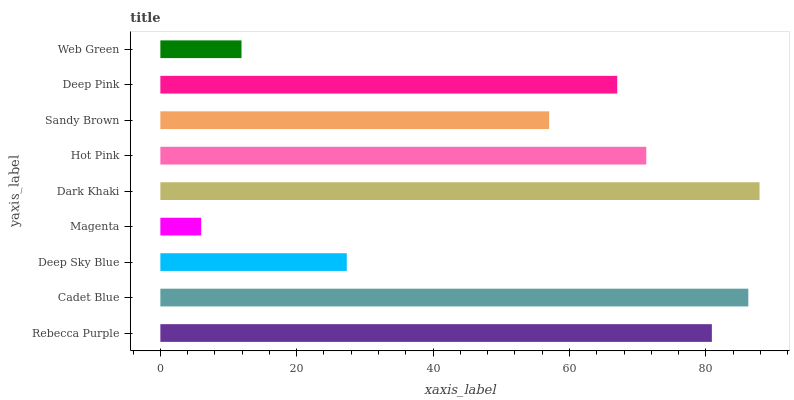Is Magenta the minimum?
Answer yes or no. Yes. Is Dark Khaki the maximum?
Answer yes or no. Yes. Is Cadet Blue the minimum?
Answer yes or no. No. Is Cadet Blue the maximum?
Answer yes or no. No. Is Cadet Blue greater than Rebecca Purple?
Answer yes or no. Yes. Is Rebecca Purple less than Cadet Blue?
Answer yes or no. Yes. Is Rebecca Purple greater than Cadet Blue?
Answer yes or no. No. Is Cadet Blue less than Rebecca Purple?
Answer yes or no. No. Is Deep Pink the high median?
Answer yes or no. Yes. Is Deep Pink the low median?
Answer yes or no. Yes. Is Rebecca Purple the high median?
Answer yes or no. No. Is Web Green the low median?
Answer yes or no. No. 